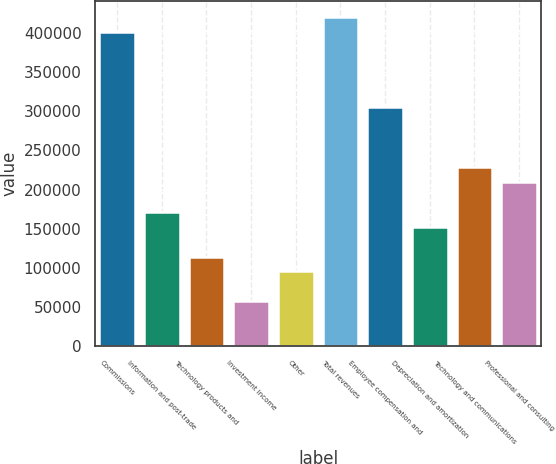<chart> <loc_0><loc_0><loc_500><loc_500><bar_chart><fcel>Commissions<fcel>Information and post-trade<fcel>Technology products and<fcel>Investment income<fcel>Other<fcel>Total revenues<fcel>Employee compensation and<fcel>Depreciation and amortization<fcel>Technology and communications<fcel>Professional and consulting<nl><fcel>400762<fcel>171756<fcel>114505<fcel>57253.2<fcel>95420.9<fcel>419846<fcel>305343<fcel>152672<fcel>229008<fcel>209924<nl></chart> 